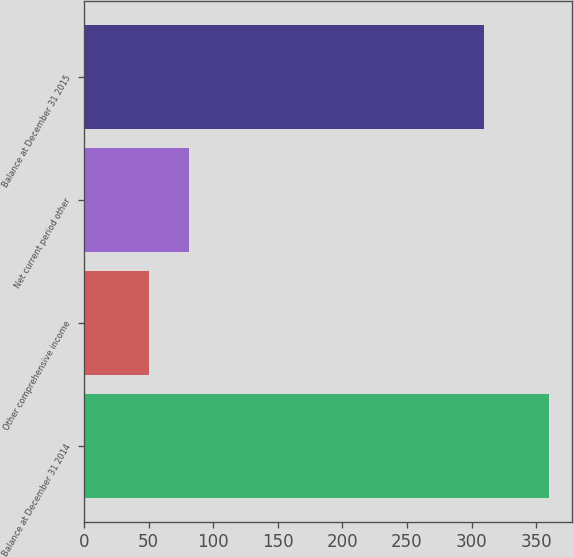Convert chart. <chart><loc_0><loc_0><loc_500><loc_500><bar_chart><fcel>Balance at December 31 2014<fcel>Other comprehensive income<fcel>Net current period other<fcel>Balance at December 31 2015<nl><fcel>360<fcel>50<fcel>81<fcel>310<nl></chart> 